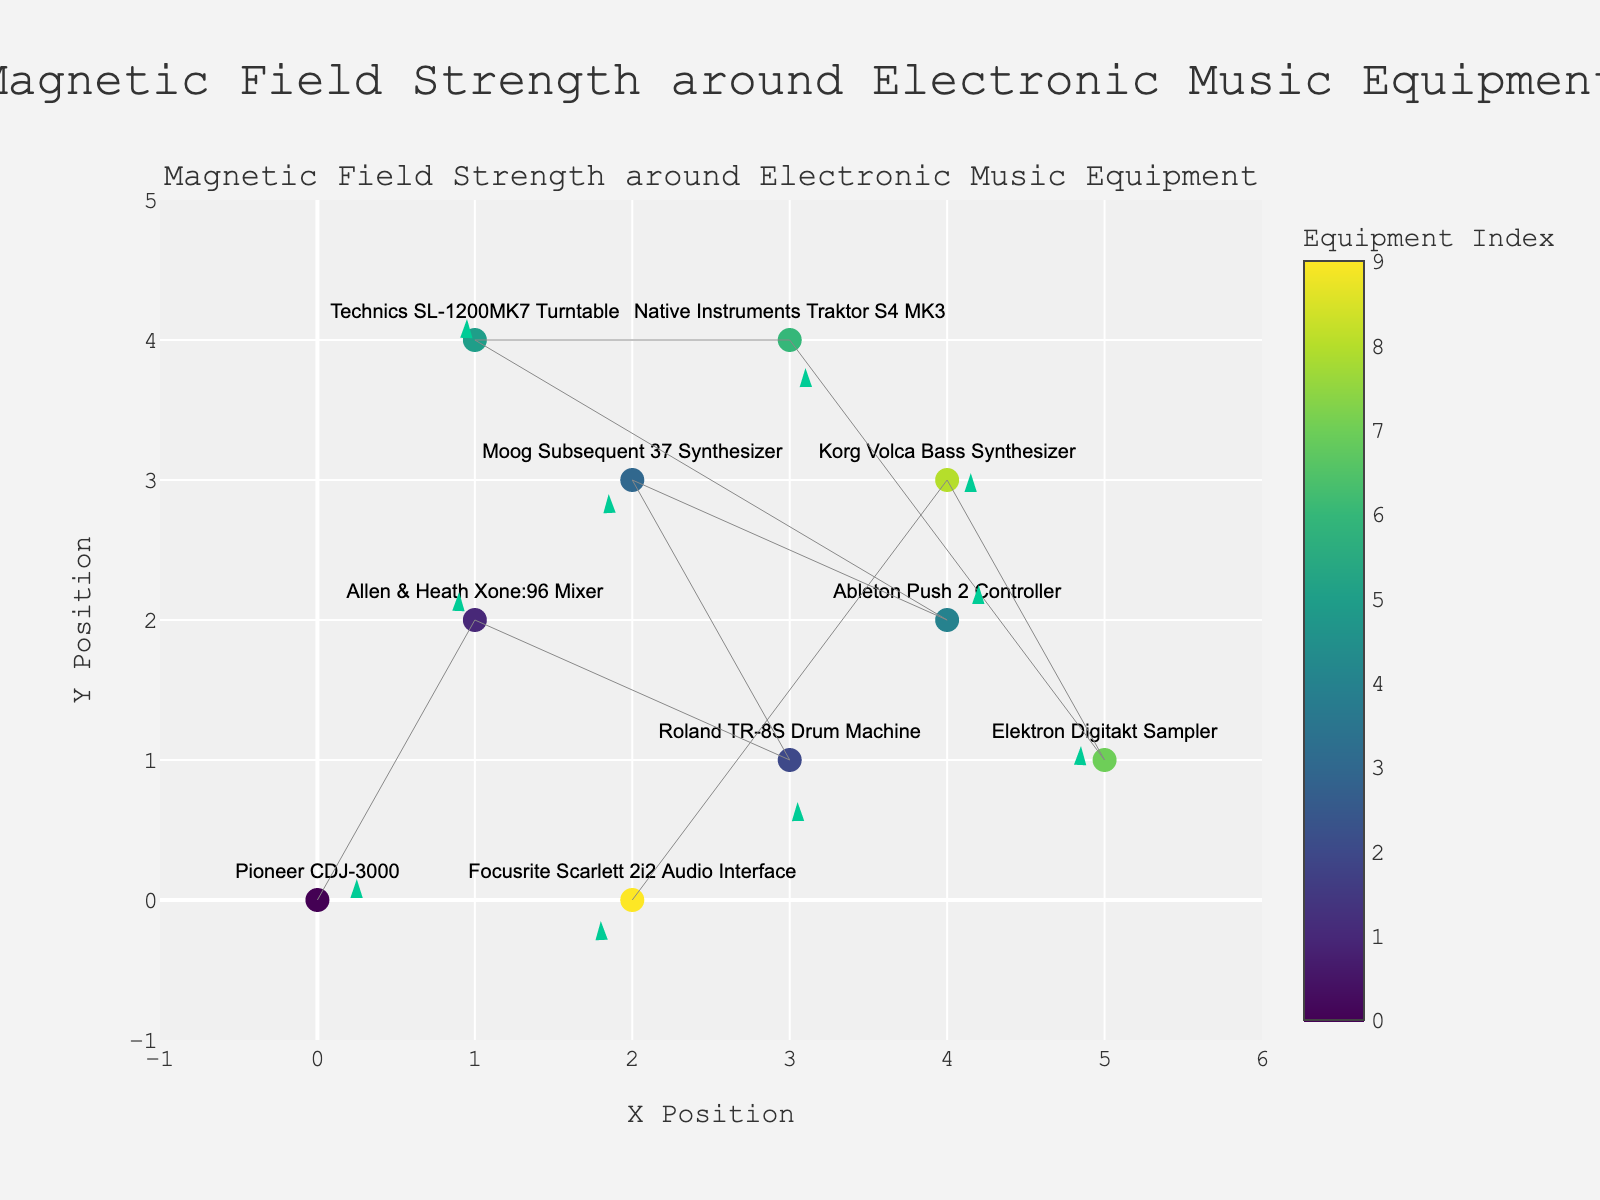How many pieces of electronic music equipment are displayed in the plot? Count the number of pieces of equipment listed in the plot, which are marked with different indices.
Answer: 10 Which equipment has the highest vertical component (v) of the magnetic field strength? Check the "v" values associated with each piece of equipment. The highest vertical component will be the one with the largest positive "v" value, Allen & Heath Xone:96 Mixer with v = 0.4.
Answer: Allen & Heath Xone:96 Mixer Which equipment is located at position (2, 0)? Find the equipment labeled with the coordinates (2, 0).
Answer: Focusrite Scarlett 2i2 Audio Interface What is the range of the x-axis? Check the x-axis of the plot to find the minimum and maximum values. The range is from -1 to 6.
Answer: -1 to 6 Which piece of equipment has a magnetic field vector pointing directly down (negative vertical component (v) and zero horizontal component (u) )? Identify the equipment with v<0 and u=0. No equipment meets this exact criterion.
Answer: None Which equipment is closer to the top of the plot, Native Instruments Traktor S4 MK3 or Technics SL-1200MK7 Turntable? Compare the y positions of both pieces of equipment. Native Instruments Traktor S4 MK3 (y=4) and Technics SL-1200MK7 Turntable (y=4), both are the same height on y-axis.
Answer: Neither, they are at the same height Calculate the average "u" component of the magnetic field strength for all equipment. Sum up all "u" values and divide by the number of equipment pieces: (0.5 - 0.2 + 0.1 - 0.3 + 0.4 - 0.1 + 0.2 - 0.3 + 0.3 - 0.4) / 10 = 0.2/10 = 0.02.
Answer: 0.02 Which direction does the magnetic field vector point for the Korg Volca Bass Synthesizer? Use the provided data to see the direction vector (u = 0.3, v = 0.1). It points slightly to the right and slightly up.
Answer: Right and slightly up 